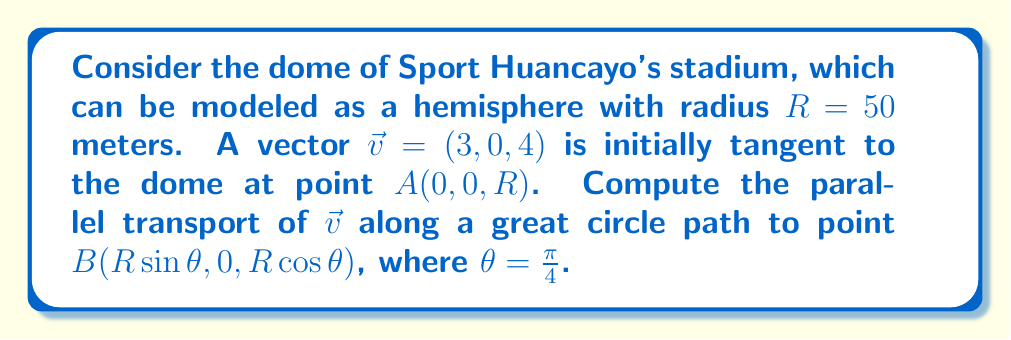Solve this math problem. To solve this problem, we'll follow these steps:

1) First, we need to understand that parallel transport preserves the angle between the vector and the path, as well as the vector's magnitude.

2) The great circle path on a sphere is described by the equation:
   $$\gamma(t) = (R\sin t, 0, R\cos t), \quad 0 \leq t \leq \theta$$

3) The tangent vector to this path is:
   $$\dot{\gamma}(t) = (R\cos t, 0, -R\sin t)$$

4) We need to find a vector $\vec{w}(t)$ that is parallel transported along $\gamma(t)$. It should satisfy:
   $$\vec{w}(t) \cdot \dot{\gamma}(t) = \text{constant}$$
   $$|\vec{w}(t)| = |\vec{v}| = 5$$

5) We can express $\vec{w}(t)$ as:
   $$\vec{w}(t) = (a\cos t + b\sin t, 0, -a\sin t + b\cos t)$$

6) Using the initial condition $\vec{w}(0) = \vec{v} = (3, 0, 4)$, we get:
   $$a = 3, \quad b = 4$$

7) Therefore, the parallel transported vector is:
   $$\vec{w}(t) = (3\cos t + 4\sin t, 0, -3\sin t + 4\cos t)$$

8) At point B, where $t = \theta = \frac{\pi}{4}$, we have:
   $$\vec{w}(\frac{\pi}{4}) = (3\cos\frac{\pi}{4} + 4\sin\frac{\pi}{4}, 0, -3\sin\frac{\pi}{4} + 4\cos\frac{\pi}{4})$$

9) Simplifying:
   $$\vec{w}(\frac{\pi}{4}) = (3\cdot\frac{\sqrt{2}}{2} + 4\cdot\frac{\sqrt{2}}{2}, 0, -3\cdot\frac{\sqrt{2}}{2} + 4\cdot\frac{\sqrt{2}}{2})$$
   $$= (\frac{7\sqrt{2}}{2}, 0, \frac{\sqrt{2}}{2})$$
Answer: $(\frac{7\sqrt{2}}{2}, 0, \frac{\sqrt{2}}{2})$ 